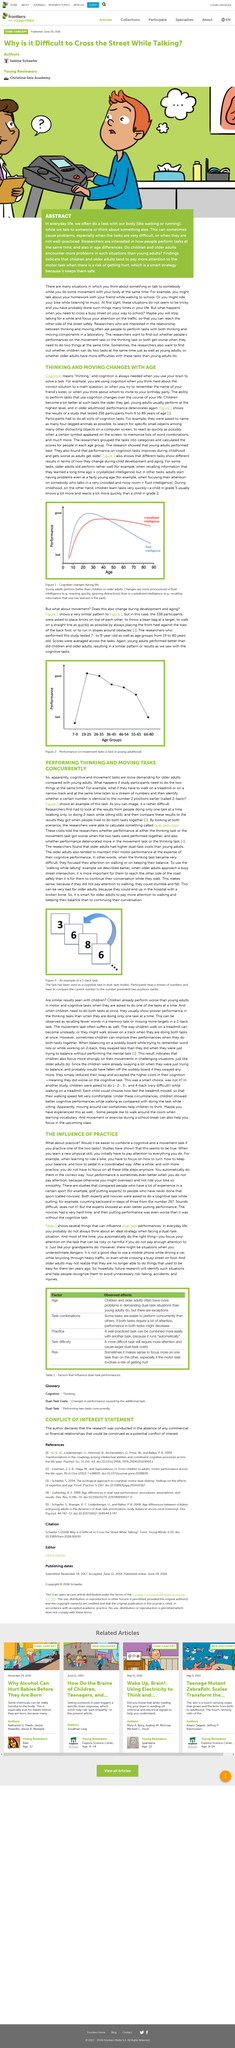Mention a couple of crucial points in this snapshot. Older adults may find cognitive and movement tasks to be more demanding than young adults, according to recent research. The youngest person tested was six years old, and they were six years old. Using a mobile phone while driving a car is not a good idea. The performance on dual-task conditions can be impacted by various factors such as age, the combination of tasks, practice, task difficulty, and risk factors. It is advisable for older adults to prioritize focusing on their walking and maintaining their balance over continuing their conversation while they are outdoors. 